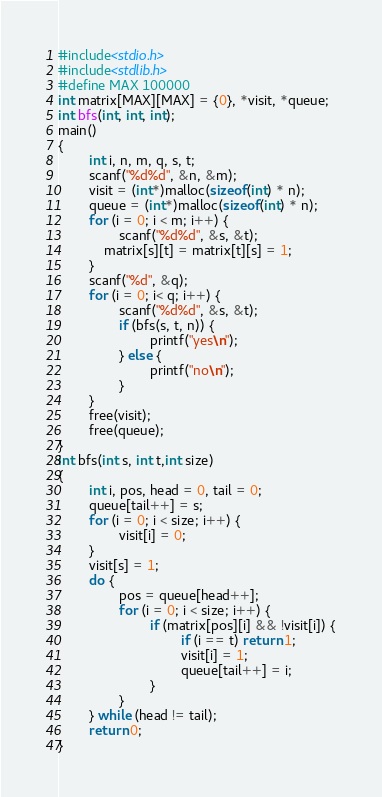Convert code to text. <code><loc_0><loc_0><loc_500><loc_500><_C_>#include<stdio.h>
#include<stdlib.h>
#define MAX 100000
int matrix[MAX][MAX] = {0}, *visit, *queue;
int bfs(int, int, int);
main()
{
        int i, n, m, q, s, t;
        scanf("%d%d", &n, &m);
        visit = (int*)malloc(sizeof(int) * n);
    	queue = (int*)malloc(sizeof(int) * n);
        for (i = 0; i < m; i++) {
                scanf("%d%d", &s, &t);
            matrix[s][t] = matrix[t][s] = 1;
        }
        scanf("%d", &q);
        for (i = 0; i< q; i++) {
                scanf("%d%d", &s, &t);
                if (bfs(s, t, n)) {
                        printf("yes\n");
                } else {
                        printf("no\n");
                }
        }
        free(visit);
        free(queue);
}
int bfs(int s, int t,int size)
{
        int i, pos, head = 0, tail = 0;
        queue[tail++] = s;
        for (i = 0; i < size; i++) {
                visit[i] = 0;
        }
        visit[s] = 1;
        do {
                pos = queue[head++];
                for (i = 0; i < size; i++) {
                        if (matrix[pos][i] && !visit[i]) {
                                if (i == t) return 1;
                                visit[i] = 1;
                                queue[tail++] = i;
                        }
                }
        } while (head != tail);
        return 0;
}
</code> 